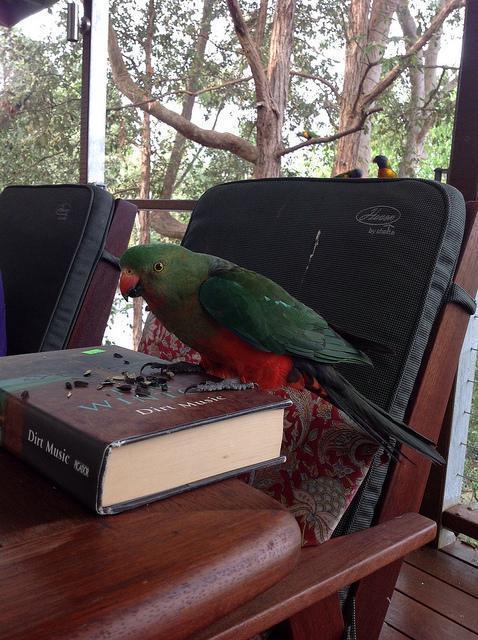How many chairs can be seen?
Give a very brief answer. 2. How many people are in the photo?
Give a very brief answer. 0. 